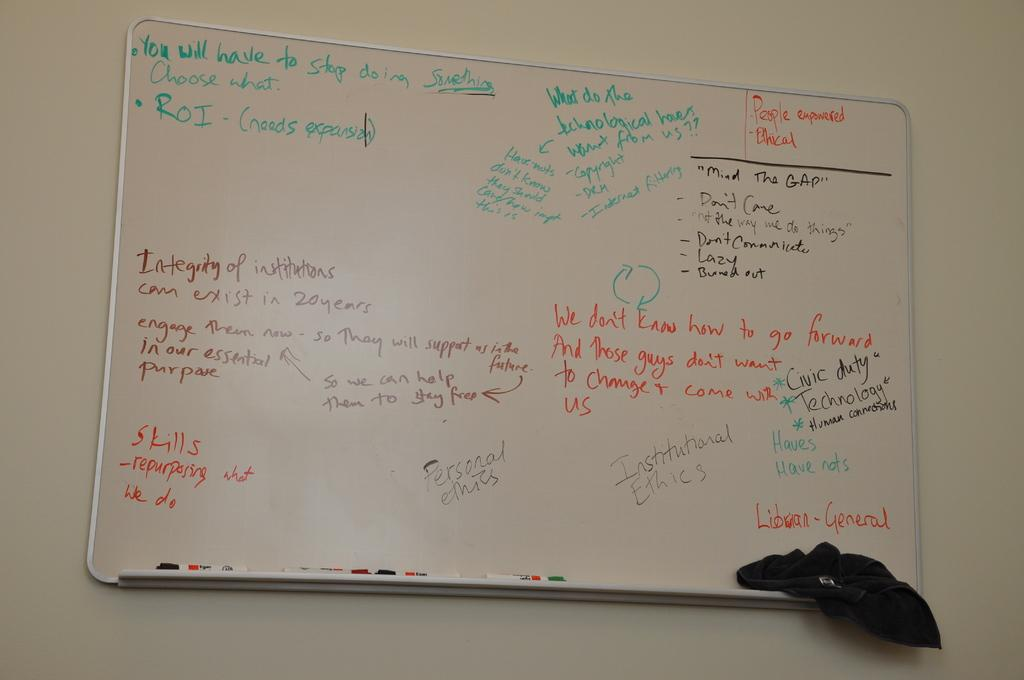<image>
Present a compact description of the photo's key features. Green text on a board says that you will have to stop doing something. 